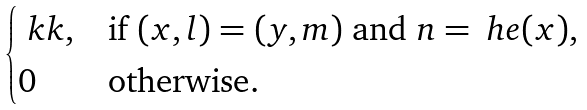Convert formula to latex. <formula><loc_0><loc_0><loc_500><loc_500>\begin{cases} \ k k , & \text {if } ( x , l ) = ( y , m ) \text { and } n = \ h e ( x ) , \quad \\ 0 & \text {otherwise} . \end{cases}</formula> 